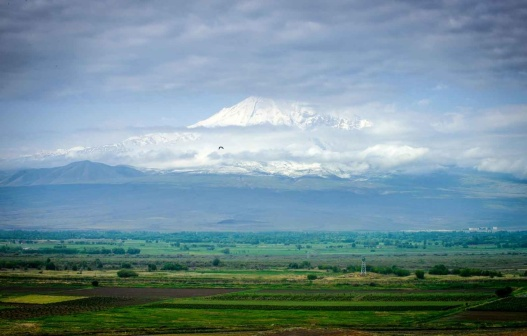In this vast landscape, imagine a great mythical creature appearing. Describe the scene in detail. As the sun hovers low in the sky, casting an amber glow across the landscape, a tremor runs through the ground. From the depths of the verdant valley, emerges a colossal dragon, its scales shimmering in the fading light with hues of emerald and gold. Its wings, spanning the breadth of many fields, unfurl, creating gusts that ripple through the trees. The mountain seems almost to bow as the dragon soars skyward, its roar echoing through the valley like thunder. The fluffy clouds, now tinged with the colors of the setting sun, part as the majestic creature climbs higher, becoming a silhouette against the twilight sky. The awe-inspiring sight leaves an indelible mark on the land, a memory to be passed down through generations. 